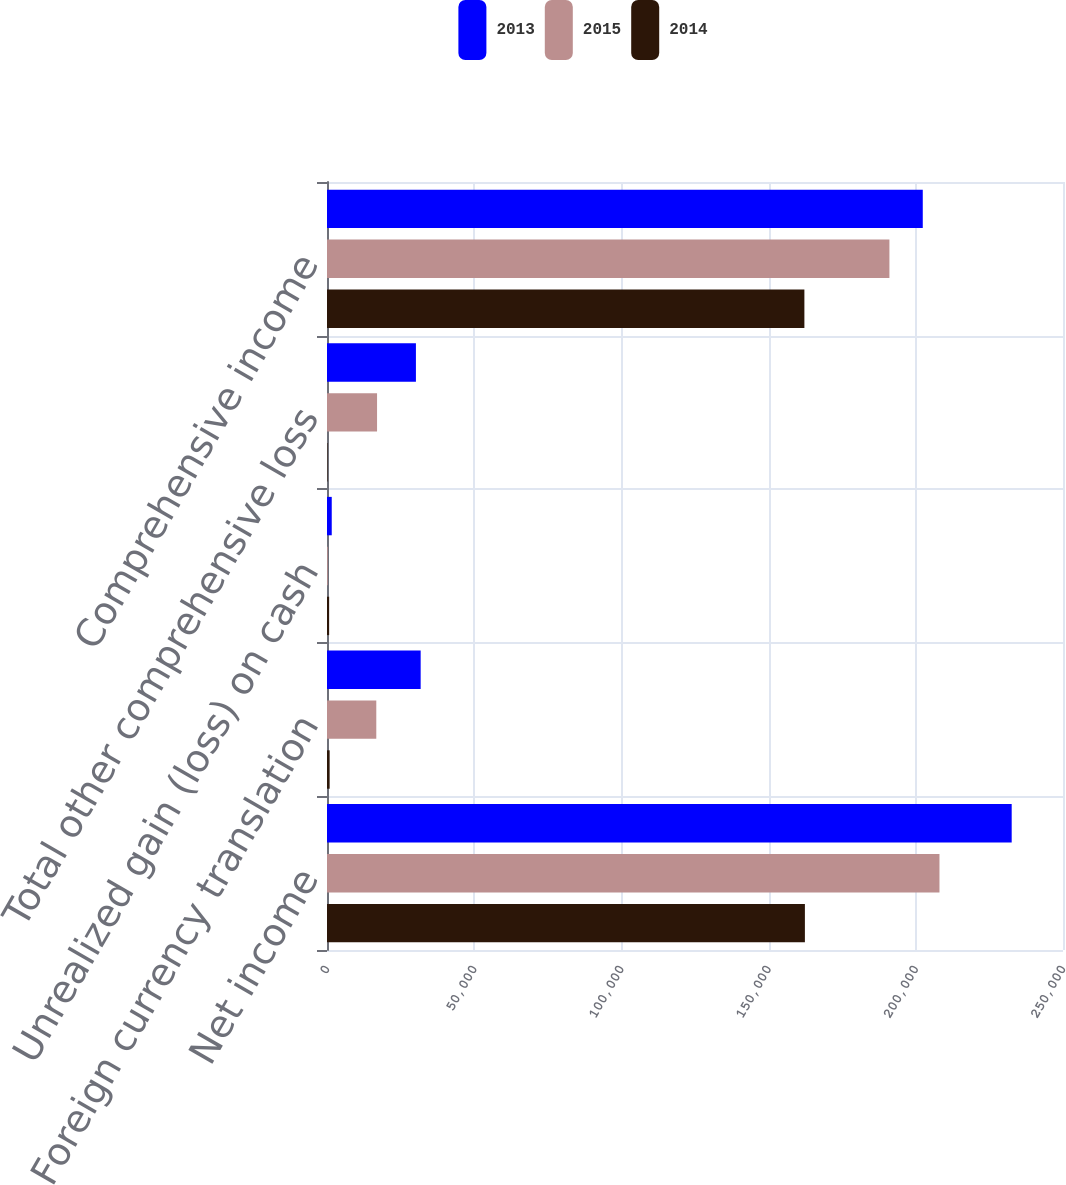Convert chart to OTSL. <chart><loc_0><loc_0><loc_500><loc_500><stacked_bar_chart><ecel><fcel>Net income<fcel>Foreign currency translation<fcel>Unrealized gain (loss) on cash<fcel>Total other comprehensive loss<fcel>Comprehensive income<nl><fcel>2013<fcel>232573<fcel>31816<fcel>1611<fcel>30205<fcel>202368<nl><fcel>2015<fcel>208042<fcel>16743<fcel>259<fcel>17002<fcel>191040<nl><fcel>2014<fcel>162330<fcel>897<fcel>723<fcel>174<fcel>162156<nl></chart> 